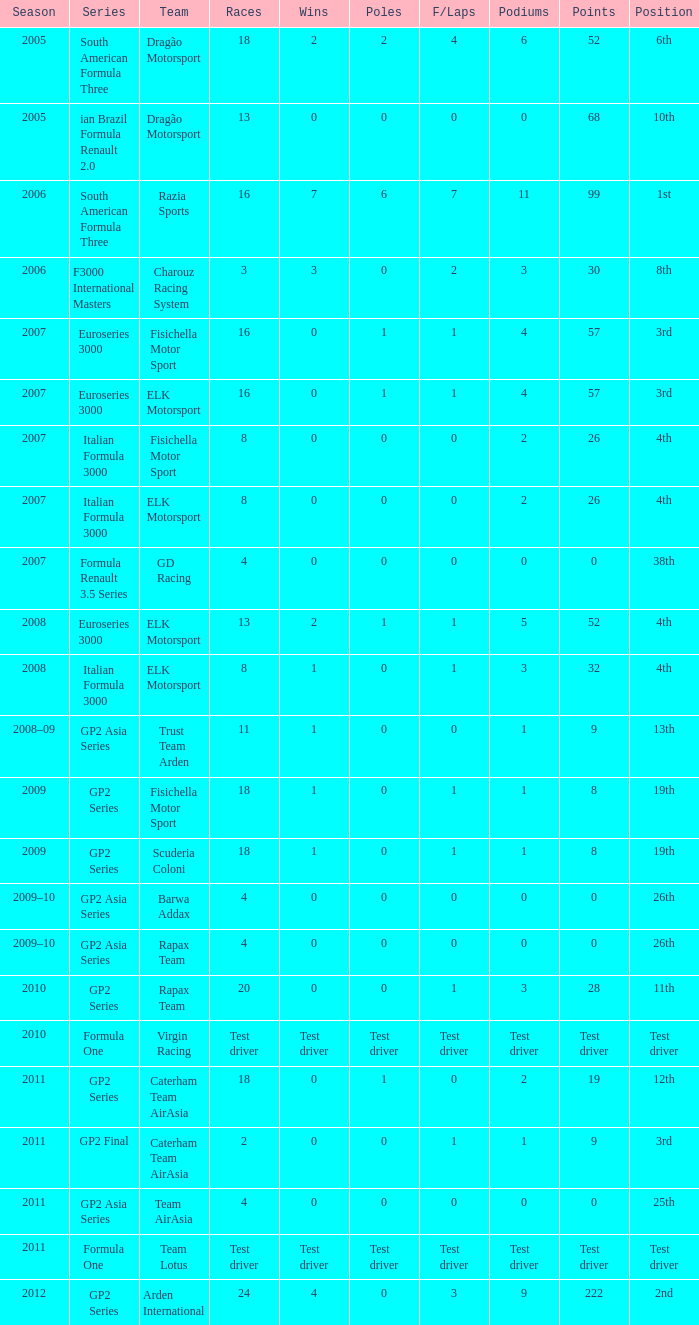What were the points in the year when his Podiums were 5? 52.0. 